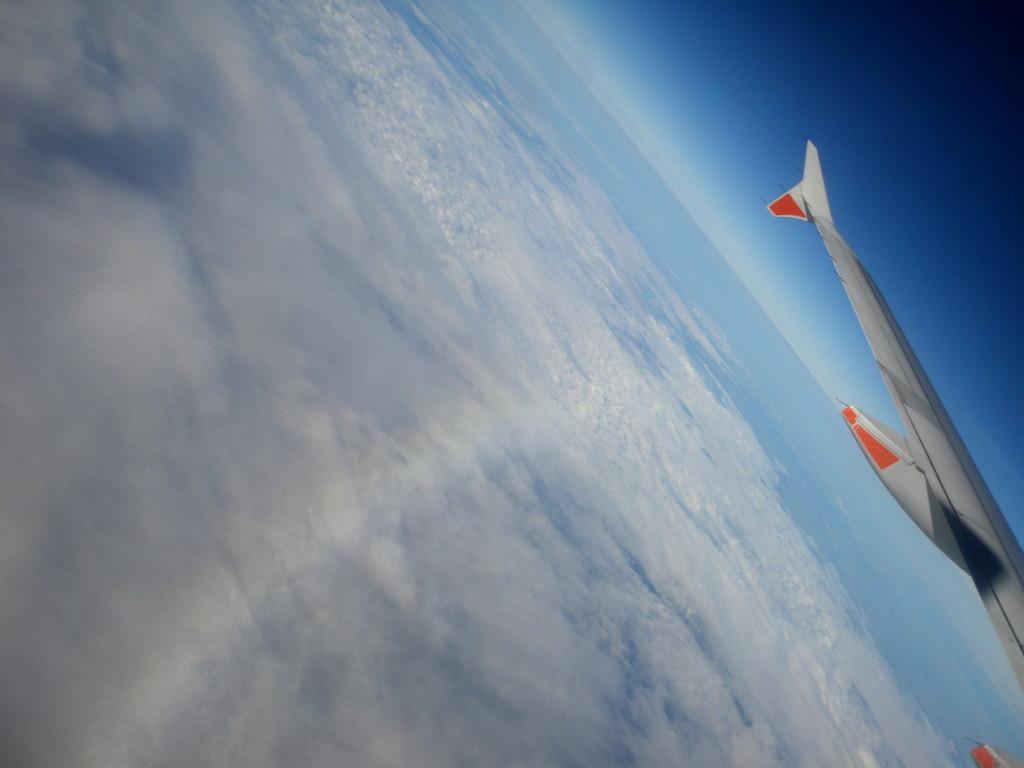Describe this image in one or two sentences. In this image we can see an aircraft in the sky and we can also see clouds. 